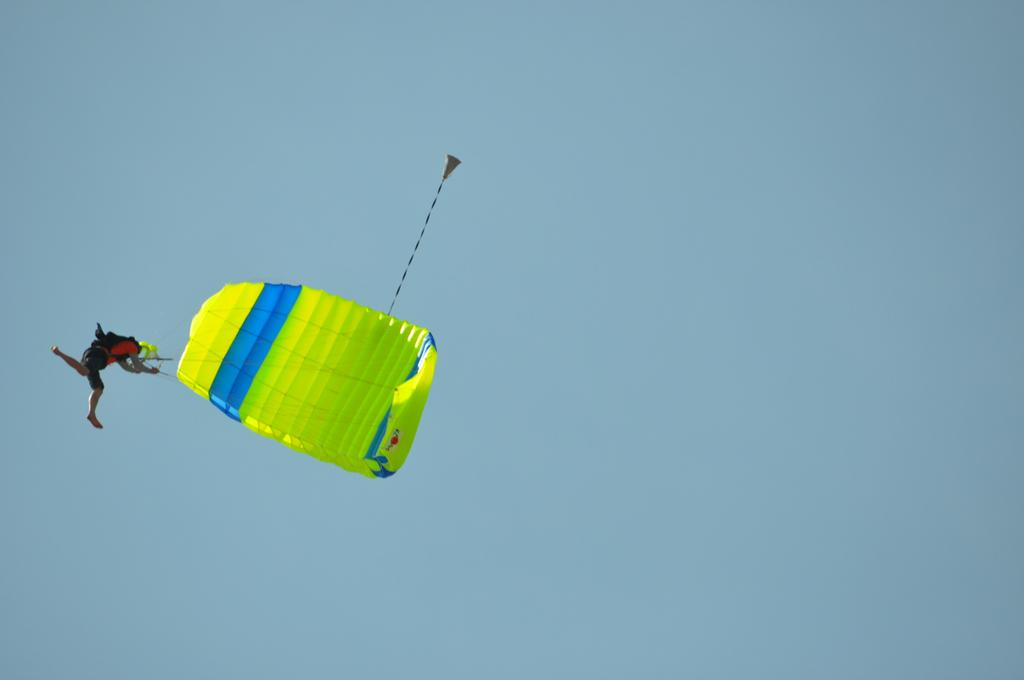What is the main subject of the image? There is a person in the image. What is the person doing in the image? The person is flying with a parachute. What type of sail can be seen in the image? There is no sail present in the image; the person is flying with a parachute. Who gave the person approval to fly with a parachute in the image? The image does not provide information about who gave the person approval to fly with a parachute. 